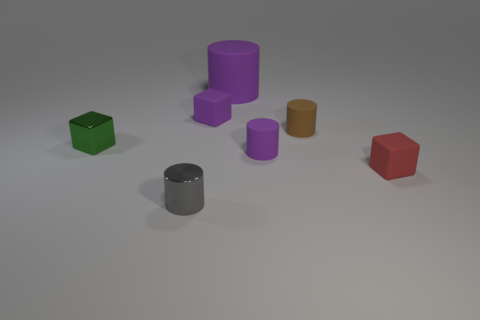There is a red object; is its size the same as the purple cylinder behind the green block?
Offer a terse response. No. The small block that is on the right side of the metal cube and in front of the purple matte block is what color?
Make the answer very short. Red. Is the number of tiny things that are in front of the small green metal cube greater than the number of blocks that are behind the brown matte cylinder?
Offer a terse response. Yes. What size is the cylinder that is made of the same material as the green cube?
Your answer should be compact. Small. How many cylinders are behind the purple cylinder in front of the large object?
Offer a very short reply. 2. Are there any green metal things that have the same shape as the gray thing?
Your response must be concise. No. What color is the small matte block in front of the metallic object behind the gray metallic cylinder?
Offer a very short reply. Red. Are there more cubes than red matte objects?
Your answer should be very brief. Yes. What number of cubes are the same size as the gray cylinder?
Your answer should be compact. 3. Do the big object and the cylinder in front of the small red block have the same material?
Provide a short and direct response. No. 